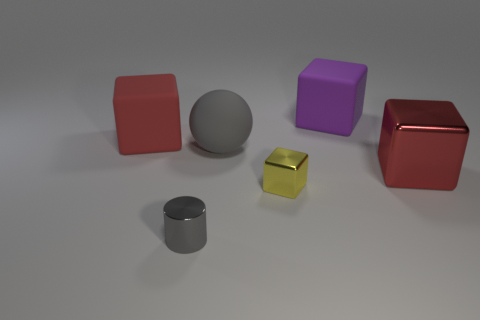What shape is the metal thing that is the same color as the rubber ball?
Offer a very short reply. Cylinder. Is there a big rubber object that has the same color as the cylinder?
Provide a succinct answer. Yes. What is the size of the metal object that is the same color as the big sphere?
Provide a short and direct response. Small. Is the color of the rubber sphere the same as the tiny object to the left of the rubber ball?
Your answer should be compact. Yes. Are there more yellow shiny cubes to the left of the tiny cylinder than large purple matte objects?
Your response must be concise. No. How many small yellow shiny cubes are to the left of the rubber thing that is in front of the red cube that is left of the yellow shiny cube?
Keep it short and to the point. 0. There is a gray matte sphere behind the yellow metallic thing; is its size the same as the cube in front of the big red metal cube?
Provide a short and direct response. No. The red block on the right side of the cube that is on the left side of the tiny yellow thing is made of what material?
Ensure brevity in your answer.  Metal. How many objects are cubes that are right of the small metallic cylinder or brown matte cubes?
Offer a terse response. 3. Are there an equal number of gray objects that are behind the large gray matte thing and red objects on the left side of the large metallic block?
Ensure brevity in your answer.  No. 